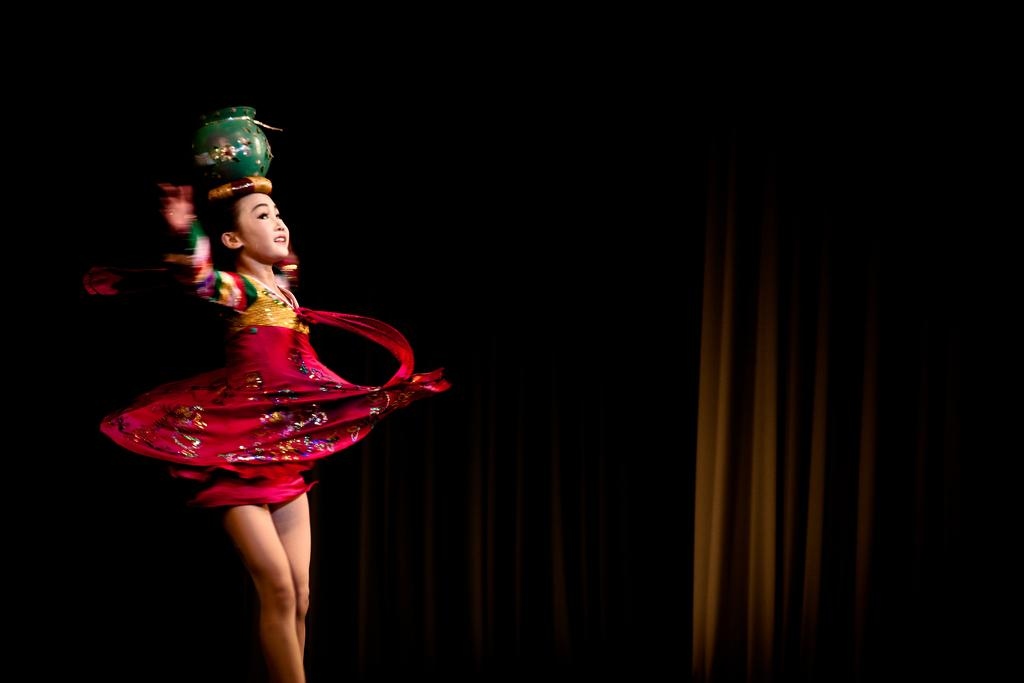Who is the main subject in the image? There is a woman in the image. What is the woman wearing? The woman is wearing a costume. What is the woman doing in the image? The woman is performing. What is the woman holding on her head? The woman is holding a pot on her head. What can be seen in the background of the image? There is a curtain in the background of the image. What type of coal is being used to fuel the hall in the image? There is no mention of a hall or coal in the image; it features a woman performing with a pot on her head. How many wings can be seen on the woman in the image? The woman is not depicted with any wings in the image. 